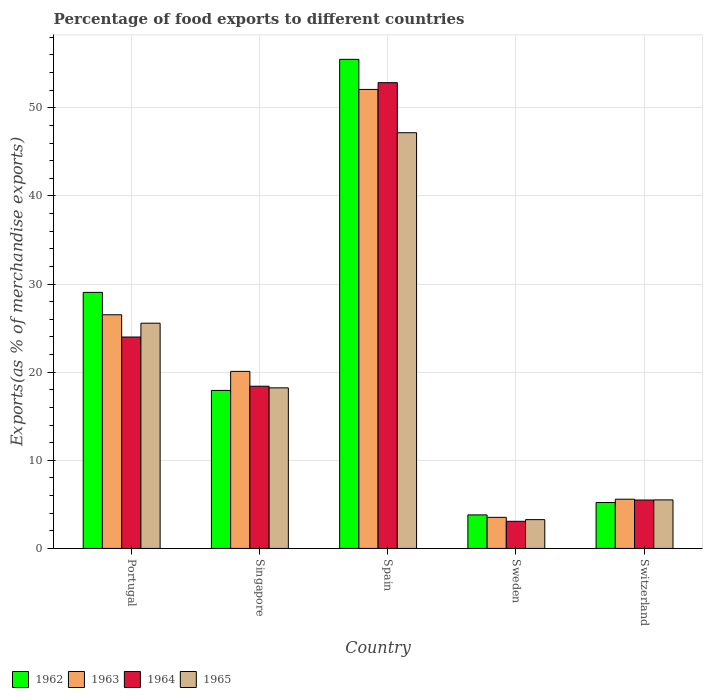How many different coloured bars are there?
Make the answer very short. 4. How many groups of bars are there?
Ensure brevity in your answer.  5. How many bars are there on the 4th tick from the left?
Ensure brevity in your answer.  4. What is the percentage of exports to different countries in 1964 in Switzerland?
Your answer should be very brief. 5.49. Across all countries, what is the maximum percentage of exports to different countries in 1962?
Offer a very short reply. 55.5. Across all countries, what is the minimum percentage of exports to different countries in 1963?
Make the answer very short. 3.53. In which country was the percentage of exports to different countries in 1963 minimum?
Keep it short and to the point. Sweden. What is the total percentage of exports to different countries in 1962 in the graph?
Your response must be concise. 111.5. What is the difference between the percentage of exports to different countries in 1965 in Portugal and that in Sweden?
Provide a short and direct response. 22.29. What is the difference between the percentage of exports to different countries in 1963 in Switzerland and the percentage of exports to different countries in 1962 in Spain?
Ensure brevity in your answer.  -49.92. What is the average percentage of exports to different countries in 1965 per country?
Make the answer very short. 19.95. What is the difference between the percentage of exports to different countries of/in 1962 and percentage of exports to different countries of/in 1963 in Singapore?
Provide a short and direct response. -2.16. What is the ratio of the percentage of exports to different countries in 1964 in Portugal to that in Sweden?
Give a very brief answer. 7.79. Is the percentage of exports to different countries in 1964 in Singapore less than that in Sweden?
Offer a terse response. No. Is the difference between the percentage of exports to different countries in 1962 in Spain and Switzerland greater than the difference between the percentage of exports to different countries in 1963 in Spain and Switzerland?
Your answer should be very brief. Yes. What is the difference between the highest and the second highest percentage of exports to different countries in 1964?
Your answer should be very brief. -34.45. What is the difference between the highest and the lowest percentage of exports to different countries in 1962?
Make the answer very short. 51.7. In how many countries, is the percentage of exports to different countries in 1965 greater than the average percentage of exports to different countries in 1965 taken over all countries?
Provide a succinct answer. 2. What does the 1st bar from the left in Singapore represents?
Offer a terse response. 1962. What does the 4th bar from the right in Singapore represents?
Give a very brief answer. 1962. How many bars are there?
Keep it short and to the point. 20. How many countries are there in the graph?
Give a very brief answer. 5. What is the difference between two consecutive major ticks on the Y-axis?
Keep it short and to the point. 10. Does the graph contain any zero values?
Keep it short and to the point. No. What is the title of the graph?
Offer a very short reply. Percentage of food exports to different countries. What is the label or title of the X-axis?
Provide a short and direct response. Country. What is the label or title of the Y-axis?
Ensure brevity in your answer.  Exports(as % of merchandise exports). What is the Exports(as % of merchandise exports) in 1962 in Portugal?
Keep it short and to the point. 29.05. What is the Exports(as % of merchandise exports) of 1963 in Portugal?
Keep it short and to the point. 26.51. What is the Exports(as % of merchandise exports) in 1964 in Portugal?
Your answer should be compact. 23.99. What is the Exports(as % of merchandise exports) of 1965 in Portugal?
Offer a very short reply. 25.56. What is the Exports(as % of merchandise exports) in 1962 in Singapore?
Offer a terse response. 17.93. What is the Exports(as % of merchandise exports) of 1963 in Singapore?
Keep it short and to the point. 20.09. What is the Exports(as % of merchandise exports) of 1964 in Singapore?
Ensure brevity in your answer.  18.41. What is the Exports(as % of merchandise exports) in 1965 in Singapore?
Offer a terse response. 18.22. What is the Exports(as % of merchandise exports) of 1962 in Spain?
Keep it short and to the point. 55.5. What is the Exports(as % of merchandise exports) of 1963 in Spain?
Offer a very short reply. 52.09. What is the Exports(as % of merchandise exports) in 1964 in Spain?
Offer a very short reply. 52.85. What is the Exports(as % of merchandise exports) in 1965 in Spain?
Ensure brevity in your answer.  47.17. What is the Exports(as % of merchandise exports) in 1962 in Sweden?
Your answer should be compact. 3.8. What is the Exports(as % of merchandise exports) in 1963 in Sweden?
Provide a succinct answer. 3.53. What is the Exports(as % of merchandise exports) in 1964 in Sweden?
Provide a succinct answer. 3.08. What is the Exports(as % of merchandise exports) in 1965 in Sweden?
Make the answer very short. 3.27. What is the Exports(as % of merchandise exports) in 1962 in Switzerland?
Your answer should be compact. 5.21. What is the Exports(as % of merchandise exports) in 1963 in Switzerland?
Ensure brevity in your answer.  5.59. What is the Exports(as % of merchandise exports) in 1964 in Switzerland?
Offer a terse response. 5.49. What is the Exports(as % of merchandise exports) in 1965 in Switzerland?
Keep it short and to the point. 5.51. Across all countries, what is the maximum Exports(as % of merchandise exports) in 1962?
Make the answer very short. 55.5. Across all countries, what is the maximum Exports(as % of merchandise exports) of 1963?
Give a very brief answer. 52.09. Across all countries, what is the maximum Exports(as % of merchandise exports) of 1964?
Offer a very short reply. 52.85. Across all countries, what is the maximum Exports(as % of merchandise exports) of 1965?
Provide a short and direct response. 47.17. Across all countries, what is the minimum Exports(as % of merchandise exports) of 1962?
Give a very brief answer. 3.8. Across all countries, what is the minimum Exports(as % of merchandise exports) of 1963?
Keep it short and to the point. 3.53. Across all countries, what is the minimum Exports(as % of merchandise exports) in 1964?
Give a very brief answer. 3.08. Across all countries, what is the minimum Exports(as % of merchandise exports) of 1965?
Offer a very short reply. 3.27. What is the total Exports(as % of merchandise exports) in 1962 in the graph?
Offer a terse response. 111.5. What is the total Exports(as % of merchandise exports) of 1963 in the graph?
Your answer should be very brief. 107.81. What is the total Exports(as % of merchandise exports) in 1964 in the graph?
Keep it short and to the point. 103.82. What is the total Exports(as % of merchandise exports) in 1965 in the graph?
Provide a short and direct response. 99.73. What is the difference between the Exports(as % of merchandise exports) in 1962 in Portugal and that in Singapore?
Your response must be concise. 11.12. What is the difference between the Exports(as % of merchandise exports) of 1963 in Portugal and that in Singapore?
Make the answer very short. 6.42. What is the difference between the Exports(as % of merchandise exports) of 1964 in Portugal and that in Singapore?
Provide a short and direct response. 5.58. What is the difference between the Exports(as % of merchandise exports) of 1965 in Portugal and that in Singapore?
Provide a short and direct response. 7.34. What is the difference between the Exports(as % of merchandise exports) of 1962 in Portugal and that in Spain?
Your answer should be very brief. -26.45. What is the difference between the Exports(as % of merchandise exports) in 1963 in Portugal and that in Spain?
Your response must be concise. -25.57. What is the difference between the Exports(as % of merchandise exports) in 1964 in Portugal and that in Spain?
Your answer should be compact. -28.86. What is the difference between the Exports(as % of merchandise exports) in 1965 in Portugal and that in Spain?
Keep it short and to the point. -21.61. What is the difference between the Exports(as % of merchandise exports) in 1962 in Portugal and that in Sweden?
Offer a very short reply. 25.25. What is the difference between the Exports(as % of merchandise exports) in 1963 in Portugal and that in Sweden?
Keep it short and to the point. 22.98. What is the difference between the Exports(as % of merchandise exports) of 1964 in Portugal and that in Sweden?
Your answer should be compact. 20.91. What is the difference between the Exports(as % of merchandise exports) of 1965 in Portugal and that in Sweden?
Your answer should be very brief. 22.29. What is the difference between the Exports(as % of merchandise exports) in 1962 in Portugal and that in Switzerland?
Your response must be concise. 23.85. What is the difference between the Exports(as % of merchandise exports) of 1963 in Portugal and that in Switzerland?
Provide a succinct answer. 20.93. What is the difference between the Exports(as % of merchandise exports) of 1964 in Portugal and that in Switzerland?
Provide a short and direct response. 18.5. What is the difference between the Exports(as % of merchandise exports) in 1965 in Portugal and that in Switzerland?
Your answer should be very brief. 20.05. What is the difference between the Exports(as % of merchandise exports) of 1962 in Singapore and that in Spain?
Offer a very short reply. -37.57. What is the difference between the Exports(as % of merchandise exports) in 1963 in Singapore and that in Spain?
Ensure brevity in your answer.  -31.99. What is the difference between the Exports(as % of merchandise exports) in 1964 in Singapore and that in Spain?
Offer a terse response. -34.45. What is the difference between the Exports(as % of merchandise exports) in 1965 in Singapore and that in Spain?
Provide a succinct answer. -28.95. What is the difference between the Exports(as % of merchandise exports) in 1962 in Singapore and that in Sweden?
Offer a very short reply. 14.13. What is the difference between the Exports(as % of merchandise exports) of 1963 in Singapore and that in Sweden?
Offer a very short reply. 16.56. What is the difference between the Exports(as % of merchandise exports) of 1964 in Singapore and that in Sweden?
Your answer should be compact. 15.33. What is the difference between the Exports(as % of merchandise exports) in 1965 in Singapore and that in Sweden?
Your response must be concise. 14.95. What is the difference between the Exports(as % of merchandise exports) in 1962 in Singapore and that in Switzerland?
Provide a short and direct response. 12.72. What is the difference between the Exports(as % of merchandise exports) in 1963 in Singapore and that in Switzerland?
Your answer should be compact. 14.51. What is the difference between the Exports(as % of merchandise exports) in 1964 in Singapore and that in Switzerland?
Ensure brevity in your answer.  12.91. What is the difference between the Exports(as % of merchandise exports) of 1965 in Singapore and that in Switzerland?
Your response must be concise. 12.71. What is the difference between the Exports(as % of merchandise exports) of 1962 in Spain and that in Sweden?
Ensure brevity in your answer.  51.7. What is the difference between the Exports(as % of merchandise exports) in 1963 in Spain and that in Sweden?
Make the answer very short. 48.56. What is the difference between the Exports(as % of merchandise exports) of 1964 in Spain and that in Sweden?
Keep it short and to the point. 49.77. What is the difference between the Exports(as % of merchandise exports) of 1965 in Spain and that in Sweden?
Provide a succinct answer. 43.9. What is the difference between the Exports(as % of merchandise exports) of 1962 in Spain and that in Switzerland?
Your answer should be compact. 50.29. What is the difference between the Exports(as % of merchandise exports) in 1963 in Spain and that in Switzerland?
Make the answer very short. 46.5. What is the difference between the Exports(as % of merchandise exports) in 1964 in Spain and that in Switzerland?
Your answer should be very brief. 47.36. What is the difference between the Exports(as % of merchandise exports) in 1965 in Spain and that in Switzerland?
Keep it short and to the point. 41.67. What is the difference between the Exports(as % of merchandise exports) in 1962 in Sweden and that in Switzerland?
Your answer should be very brief. -1.4. What is the difference between the Exports(as % of merchandise exports) of 1963 in Sweden and that in Switzerland?
Provide a short and direct response. -2.06. What is the difference between the Exports(as % of merchandise exports) of 1964 in Sweden and that in Switzerland?
Your response must be concise. -2.41. What is the difference between the Exports(as % of merchandise exports) in 1965 in Sweden and that in Switzerland?
Provide a short and direct response. -2.24. What is the difference between the Exports(as % of merchandise exports) in 1962 in Portugal and the Exports(as % of merchandise exports) in 1963 in Singapore?
Your answer should be compact. 8.96. What is the difference between the Exports(as % of merchandise exports) in 1962 in Portugal and the Exports(as % of merchandise exports) in 1964 in Singapore?
Offer a terse response. 10.65. What is the difference between the Exports(as % of merchandise exports) of 1962 in Portugal and the Exports(as % of merchandise exports) of 1965 in Singapore?
Your answer should be very brief. 10.83. What is the difference between the Exports(as % of merchandise exports) in 1963 in Portugal and the Exports(as % of merchandise exports) in 1964 in Singapore?
Provide a short and direct response. 8.11. What is the difference between the Exports(as % of merchandise exports) of 1963 in Portugal and the Exports(as % of merchandise exports) of 1965 in Singapore?
Give a very brief answer. 8.29. What is the difference between the Exports(as % of merchandise exports) of 1964 in Portugal and the Exports(as % of merchandise exports) of 1965 in Singapore?
Your answer should be compact. 5.77. What is the difference between the Exports(as % of merchandise exports) in 1962 in Portugal and the Exports(as % of merchandise exports) in 1963 in Spain?
Your answer should be compact. -23.03. What is the difference between the Exports(as % of merchandise exports) of 1962 in Portugal and the Exports(as % of merchandise exports) of 1964 in Spain?
Make the answer very short. -23.8. What is the difference between the Exports(as % of merchandise exports) of 1962 in Portugal and the Exports(as % of merchandise exports) of 1965 in Spain?
Provide a succinct answer. -18.12. What is the difference between the Exports(as % of merchandise exports) in 1963 in Portugal and the Exports(as % of merchandise exports) in 1964 in Spain?
Your answer should be compact. -26.34. What is the difference between the Exports(as % of merchandise exports) in 1963 in Portugal and the Exports(as % of merchandise exports) in 1965 in Spain?
Your response must be concise. -20.66. What is the difference between the Exports(as % of merchandise exports) of 1964 in Portugal and the Exports(as % of merchandise exports) of 1965 in Spain?
Your answer should be compact. -23.18. What is the difference between the Exports(as % of merchandise exports) of 1962 in Portugal and the Exports(as % of merchandise exports) of 1963 in Sweden?
Ensure brevity in your answer.  25.53. What is the difference between the Exports(as % of merchandise exports) of 1962 in Portugal and the Exports(as % of merchandise exports) of 1964 in Sweden?
Provide a succinct answer. 25.98. What is the difference between the Exports(as % of merchandise exports) of 1962 in Portugal and the Exports(as % of merchandise exports) of 1965 in Sweden?
Provide a succinct answer. 25.79. What is the difference between the Exports(as % of merchandise exports) in 1963 in Portugal and the Exports(as % of merchandise exports) in 1964 in Sweden?
Your response must be concise. 23.44. What is the difference between the Exports(as % of merchandise exports) of 1963 in Portugal and the Exports(as % of merchandise exports) of 1965 in Sweden?
Make the answer very short. 23.25. What is the difference between the Exports(as % of merchandise exports) in 1964 in Portugal and the Exports(as % of merchandise exports) in 1965 in Sweden?
Your answer should be compact. 20.72. What is the difference between the Exports(as % of merchandise exports) of 1962 in Portugal and the Exports(as % of merchandise exports) of 1963 in Switzerland?
Provide a short and direct response. 23.47. What is the difference between the Exports(as % of merchandise exports) of 1962 in Portugal and the Exports(as % of merchandise exports) of 1964 in Switzerland?
Offer a terse response. 23.56. What is the difference between the Exports(as % of merchandise exports) in 1962 in Portugal and the Exports(as % of merchandise exports) in 1965 in Switzerland?
Make the answer very short. 23.55. What is the difference between the Exports(as % of merchandise exports) in 1963 in Portugal and the Exports(as % of merchandise exports) in 1964 in Switzerland?
Your answer should be very brief. 21.02. What is the difference between the Exports(as % of merchandise exports) in 1963 in Portugal and the Exports(as % of merchandise exports) in 1965 in Switzerland?
Your answer should be compact. 21.01. What is the difference between the Exports(as % of merchandise exports) in 1964 in Portugal and the Exports(as % of merchandise exports) in 1965 in Switzerland?
Offer a very short reply. 18.48. What is the difference between the Exports(as % of merchandise exports) of 1962 in Singapore and the Exports(as % of merchandise exports) of 1963 in Spain?
Ensure brevity in your answer.  -34.16. What is the difference between the Exports(as % of merchandise exports) in 1962 in Singapore and the Exports(as % of merchandise exports) in 1964 in Spain?
Provide a succinct answer. -34.92. What is the difference between the Exports(as % of merchandise exports) in 1962 in Singapore and the Exports(as % of merchandise exports) in 1965 in Spain?
Make the answer very short. -29.24. What is the difference between the Exports(as % of merchandise exports) of 1963 in Singapore and the Exports(as % of merchandise exports) of 1964 in Spain?
Provide a succinct answer. -32.76. What is the difference between the Exports(as % of merchandise exports) in 1963 in Singapore and the Exports(as % of merchandise exports) in 1965 in Spain?
Ensure brevity in your answer.  -27.08. What is the difference between the Exports(as % of merchandise exports) in 1964 in Singapore and the Exports(as % of merchandise exports) in 1965 in Spain?
Ensure brevity in your answer.  -28.77. What is the difference between the Exports(as % of merchandise exports) in 1962 in Singapore and the Exports(as % of merchandise exports) in 1963 in Sweden?
Give a very brief answer. 14.4. What is the difference between the Exports(as % of merchandise exports) in 1962 in Singapore and the Exports(as % of merchandise exports) in 1964 in Sweden?
Offer a very short reply. 14.85. What is the difference between the Exports(as % of merchandise exports) of 1962 in Singapore and the Exports(as % of merchandise exports) of 1965 in Sweden?
Keep it short and to the point. 14.66. What is the difference between the Exports(as % of merchandise exports) of 1963 in Singapore and the Exports(as % of merchandise exports) of 1964 in Sweden?
Offer a terse response. 17.01. What is the difference between the Exports(as % of merchandise exports) in 1963 in Singapore and the Exports(as % of merchandise exports) in 1965 in Sweden?
Offer a terse response. 16.83. What is the difference between the Exports(as % of merchandise exports) in 1964 in Singapore and the Exports(as % of merchandise exports) in 1965 in Sweden?
Provide a succinct answer. 15.14. What is the difference between the Exports(as % of merchandise exports) in 1962 in Singapore and the Exports(as % of merchandise exports) in 1963 in Switzerland?
Offer a terse response. 12.34. What is the difference between the Exports(as % of merchandise exports) of 1962 in Singapore and the Exports(as % of merchandise exports) of 1964 in Switzerland?
Keep it short and to the point. 12.44. What is the difference between the Exports(as % of merchandise exports) in 1962 in Singapore and the Exports(as % of merchandise exports) in 1965 in Switzerland?
Your answer should be very brief. 12.42. What is the difference between the Exports(as % of merchandise exports) in 1963 in Singapore and the Exports(as % of merchandise exports) in 1964 in Switzerland?
Provide a succinct answer. 14.6. What is the difference between the Exports(as % of merchandise exports) in 1963 in Singapore and the Exports(as % of merchandise exports) in 1965 in Switzerland?
Offer a very short reply. 14.59. What is the difference between the Exports(as % of merchandise exports) in 1964 in Singapore and the Exports(as % of merchandise exports) in 1965 in Switzerland?
Make the answer very short. 12.9. What is the difference between the Exports(as % of merchandise exports) of 1962 in Spain and the Exports(as % of merchandise exports) of 1963 in Sweden?
Your answer should be compact. 51.97. What is the difference between the Exports(as % of merchandise exports) of 1962 in Spain and the Exports(as % of merchandise exports) of 1964 in Sweden?
Provide a short and direct response. 52.42. What is the difference between the Exports(as % of merchandise exports) in 1962 in Spain and the Exports(as % of merchandise exports) in 1965 in Sweden?
Offer a terse response. 52.23. What is the difference between the Exports(as % of merchandise exports) in 1963 in Spain and the Exports(as % of merchandise exports) in 1964 in Sweden?
Make the answer very short. 49.01. What is the difference between the Exports(as % of merchandise exports) of 1963 in Spain and the Exports(as % of merchandise exports) of 1965 in Sweden?
Offer a terse response. 48.82. What is the difference between the Exports(as % of merchandise exports) in 1964 in Spain and the Exports(as % of merchandise exports) in 1965 in Sweden?
Provide a succinct answer. 49.58. What is the difference between the Exports(as % of merchandise exports) of 1962 in Spain and the Exports(as % of merchandise exports) of 1963 in Switzerland?
Offer a very short reply. 49.92. What is the difference between the Exports(as % of merchandise exports) in 1962 in Spain and the Exports(as % of merchandise exports) in 1964 in Switzerland?
Offer a terse response. 50.01. What is the difference between the Exports(as % of merchandise exports) in 1962 in Spain and the Exports(as % of merchandise exports) in 1965 in Switzerland?
Make the answer very short. 49.99. What is the difference between the Exports(as % of merchandise exports) in 1963 in Spain and the Exports(as % of merchandise exports) in 1964 in Switzerland?
Make the answer very short. 46.59. What is the difference between the Exports(as % of merchandise exports) in 1963 in Spain and the Exports(as % of merchandise exports) in 1965 in Switzerland?
Offer a very short reply. 46.58. What is the difference between the Exports(as % of merchandise exports) of 1964 in Spain and the Exports(as % of merchandise exports) of 1965 in Switzerland?
Your response must be concise. 47.35. What is the difference between the Exports(as % of merchandise exports) in 1962 in Sweden and the Exports(as % of merchandise exports) in 1963 in Switzerland?
Give a very brief answer. -1.78. What is the difference between the Exports(as % of merchandise exports) in 1962 in Sweden and the Exports(as % of merchandise exports) in 1964 in Switzerland?
Provide a succinct answer. -1.69. What is the difference between the Exports(as % of merchandise exports) in 1962 in Sweden and the Exports(as % of merchandise exports) in 1965 in Switzerland?
Keep it short and to the point. -1.7. What is the difference between the Exports(as % of merchandise exports) of 1963 in Sweden and the Exports(as % of merchandise exports) of 1964 in Switzerland?
Make the answer very short. -1.96. What is the difference between the Exports(as % of merchandise exports) in 1963 in Sweden and the Exports(as % of merchandise exports) in 1965 in Switzerland?
Keep it short and to the point. -1.98. What is the difference between the Exports(as % of merchandise exports) in 1964 in Sweden and the Exports(as % of merchandise exports) in 1965 in Switzerland?
Keep it short and to the point. -2.43. What is the average Exports(as % of merchandise exports) of 1962 per country?
Make the answer very short. 22.3. What is the average Exports(as % of merchandise exports) in 1963 per country?
Your answer should be very brief. 21.56. What is the average Exports(as % of merchandise exports) of 1964 per country?
Your answer should be very brief. 20.76. What is the average Exports(as % of merchandise exports) of 1965 per country?
Keep it short and to the point. 19.95. What is the difference between the Exports(as % of merchandise exports) of 1962 and Exports(as % of merchandise exports) of 1963 in Portugal?
Provide a succinct answer. 2.54. What is the difference between the Exports(as % of merchandise exports) of 1962 and Exports(as % of merchandise exports) of 1964 in Portugal?
Provide a succinct answer. 5.06. What is the difference between the Exports(as % of merchandise exports) of 1962 and Exports(as % of merchandise exports) of 1965 in Portugal?
Provide a succinct answer. 3.49. What is the difference between the Exports(as % of merchandise exports) of 1963 and Exports(as % of merchandise exports) of 1964 in Portugal?
Your answer should be very brief. 2.52. What is the difference between the Exports(as % of merchandise exports) of 1963 and Exports(as % of merchandise exports) of 1965 in Portugal?
Offer a very short reply. 0.95. What is the difference between the Exports(as % of merchandise exports) in 1964 and Exports(as % of merchandise exports) in 1965 in Portugal?
Offer a terse response. -1.57. What is the difference between the Exports(as % of merchandise exports) of 1962 and Exports(as % of merchandise exports) of 1963 in Singapore?
Offer a very short reply. -2.16. What is the difference between the Exports(as % of merchandise exports) in 1962 and Exports(as % of merchandise exports) in 1964 in Singapore?
Offer a very short reply. -0.48. What is the difference between the Exports(as % of merchandise exports) of 1962 and Exports(as % of merchandise exports) of 1965 in Singapore?
Make the answer very short. -0.29. What is the difference between the Exports(as % of merchandise exports) of 1963 and Exports(as % of merchandise exports) of 1964 in Singapore?
Ensure brevity in your answer.  1.69. What is the difference between the Exports(as % of merchandise exports) of 1963 and Exports(as % of merchandise exports) of 1965 in Singapore?
Your answer should be very brief. 1.87. What is the difference between the Exports(as % of merchandise exports) of 1964 and Exports(as % of merchandise exports) of 1965 in Singapore?
Keep it short and to the point. 0.18. What is the difference between the Exports(as % of merchandise exports) in 1962 and Exports(as % of merchandise exports) in 1963 in Spain?
Provide a succinct answer. 3.42. What is the difference between the Exports(as % of merchandise exports) in 1962 and Exports(as % of merchandise exports) in 1964 in Spain?
Offer a terse response. 2.65. What is the difference between the Exports(as % of merchandise exports) of 1962 and Exports(as % of merchandise exports) of 1965 in Spain?
Offer a terse response. 8.33. What is the difference between the Exports(as % of merchandise exports) in 1963 and Exports(as % of merchandise exports) in 1964 in Spain?
Offer a very short reply. -0.77. What is the difference between the Exports(as % of merchandise exports) of 1963 and Exports(as % of merchandise exports) of 1965 in Spain?
Ensure brevity in your answer.  4.91. What is the difference between the Exports(as % of merchandise exports) in 1964 and Exports(as % of merchandise exports) in 1965 in Spain?
Your answer should be compact. 5.68. What is the difference between the Exports(as % of merchandise exports) of 1962 and Exports(as % of merchandise exports) of 1963 in Sweden?
Provide a succinct answer. 0.28. What is the difference between the Exports(as % of merchandise exports) in 1962 and Exports(as % of merchandise exports) in 1964 in Sweden?
Provide a short and direct response. 0.73. What is the difference between the Exports(as % of merchandise exports) in 1962 and Exports(as % of merchandise exports) in 1965 in Sweden?
Ensure brevity in your answer.  0.54. What is the difference between the Exports(as % of merchandise exports) of 1963 and Exports(as % of merchandise exports) of 1964 in Sweden?
Your answer should be very brief. 0.45. What is the difference between the Exports(as % of merchandise exports) of 1963 and Exports(as % of merchandise exports) of 1965 in Sweden?
Your answer should be compact. 0.26. What is the difference between the Exports(as % of merchandise exports) in 1964 and Exports(as % of merchandise exports) in 1965 in Sweden?
Offer a very short reply. -0.19. What is the difference between the Exports(as % of merchandise exports) in 1962 and Exports(as % of merchandise exports) in 1963 in Switzerland?
Give a very brief answer. -0.38. What is the difference between the Exports(as % of merchandise exports) in 1962 and Exports(as % of merchandise exports) in 1964 in Switzerland?
Keep it short and to the point. -0.28. What is the difference between the Exports(as % of merchandise exports) of 1962 and Exports(as % of merchandise exports) of 1965 in Switzerland?
Provide a short and direct response. -0.3. What is the difference between the Exports(as % of merchandise exports) in 1963 and Exports(as % of merchandise exports) in 1964 in Switzerland?
Make the answer very short. 0.09. What is the difference between the Exports(as % of merchandise exports) in 1963 and Exports(as % of merchandise exports) in 1965 in Switzerland?
Give a very brief answer. 0.08. What is the difference between the Exports(as % of merchandise exports) of 1964 and Exports(as % of merchandise exports) of 1965 in Switzerland?
Offer a very short reply. -0.01. What is the ratio of the Exports(as % of merchandise exports) in 1962 in Portugal to that in Singapore?
Keep it short and to the point. 1.62. What is the ratio of the Exports(as % of merchandise exports) in 1963 in Portugal to that in Singapore?
Your response must be concise. 1.32. What is the ratio of the Exports(as % of merchandise exports) of 1964 in Portugal to that in Singapore?
Offer a very short reply. 1.3. What is the ratio of the Exports(as % of merchandise exports) in 1965 in Portugal to that in Singapore?
Provide a short and direct response. 1.4. What is the ratio of the Exports(as % of merchandise exports) in 1962 in Portugal to that in Spain?
Your answer should be very brief. 0.52. What is the ratio of the Exports(as % of merchandise exports) in 1963 in Portugal to that in Spain?
Offer a terse response. 0.51. What is the ratio of the Exports(as % of merchandise exports) of 1964 in Portugal to that in Spain?
Offer a very short reply. 0.45. What is the ratio of the Exports(as % of merchandise exports) of 1965 in Portugal to that in Spain?
Provide a short and direct response. 0.54. What is the ratio of the Exports(as % of merchandise exports) in 1962 in Portugal to that in Sweden?
Your answer should be compact. 7.64. What is the ratio of the Exports(as % of merchandise exports) in 1963 in Portugal to that in Sweden?
Ensure brevity in your answer.  7.51. What is the ratio of the Exports(as % of merchandise exports) in 1964 in Portugal to that in Sweden?
Offer a terse response. 7.79. What is the ratio of the Exports(as % of merchandise exports) in 1965 in Portugal to that in Sweden?
Provide a succinct answer. 7.82. What is the ratio of the Exports(as % of merchandise exports) in 1962 in Portugal to that in Switzerland?
Ensure brevity in your answer.  5.58. What is the ratio of the Exports(as % of merchandise exports) of 1963 in Portugal to that in Switzerland?
Your answer should be very brief. 4.75. What is the ratio of the Exports(as % of merchandise exports) in 1964 in Portugal to that in Switzerland?
Make the answer very short. 4.37. What is the ratio of the Exports(as % of merchandise exports) of 1965 in Portugal to that in Switzerland?
Offer a very short reply. 4.64. What is the ratio of the Exports(as % of merchandise exports) in 1962 in Singapore to that in Spain?
Provide a succinct answer. 0.32. What is the ratio of the Exports(as % of merchandise exports) of 1963 in Singapore to that in Spain?
Offer a very short reply. 0.39. What is the ratio of the Exports(as % of merchandise exports) of 1964 in Singapore to that in Spain?
Offer a very short reply. 0.35. What is the ratio of the Exports(as % of merchandise exports) of 1965 in Singapore to that in Spain?
Provide a succinct answer. 0.39. What is the ratio of the Exports(as % of merchandise exports) of 1962 in Singapore to that in Sweden?
Offer a very short reply. 4.71. What is the ratio of the Exports(as % of merchandise exports) of 1963 in Singapore to that in Sweden?
Offer a very short reply. 5.69. What is the ratio of the Exports(as % of merchandise exports) of 1964 in Singapore to that in Sweden?
Your answer should be compact. 5.98. What is the ratio of the Exports(as % of merchandise exports) of 1965 in Singapore to that in Sweden?
Keep it short and to the point. 5.58. What is the ratio of the Exports(as % of merchandise exports) in 1962 in Singapore to that in Switzerland?
Your answer should be very brief. 3.44. What is the ratio of the Exports(as % of merchandise exports) of 1963 in Singapore to that in Switzerland?
Your answer should be very brief. 3.6. What is the ratio of the Exports(as % of merchandise exports) of 1964 in Singapore to that in Switzerland?
Offer a terse response. 3.35. What is the ratio of the Exports(as % of merchandise exports) of 1965 in Singapore to that in Switzerland?
Keep it short and to the point. 3.31. What is the ratio of the Exports(as % of merchandise exports) of 1962 in Spain to that in Sweden?
Your answer should be very brief. 14.59. What is the ratio of the Exports(as % of merchandise exports) in 1963 in Spain to that in Sweden?
Give a very brief answer. 14.76. What is the ratio of the Exports(as % of merchandise exports) in 1964 in Spain to that in Sweden?
Provide a short and direct response. 17.17. What is the ratio of the Exports(as % of merchandise exports) in 1965 in Spain to that in Sweden?
Your response must be concise. 14.44. What is the ratio of the Exports(as % of merchandise exports) in 1962 in Spain to that in Switzerland?
Your response must be concise. 10.65. What is the ratio of the Exports(as % of merchandise exports) of 1963 in Spain to that in Switzerland?
Offer a very short reply. 9.33. What is the ratio of the Exports(as % of merchandise exports) of 1964 in Spain to that in Switzerland?
Offer a terse response. 9.62. What is the ratio of the Exports(as % of merchandise exports) in 1965 in Spain to that in Switzerland?
Give a very brief answer. 8.57. What is the ratio of the Exports(as % of merchandise exports) of 1962 in Sweden to that in Switzerland?
Provide a short and direct response. 0.73. What is the ratio of the Exports(as % of merchandise exports) of 1963 in Sweden to that in Switzerland?
Your response must be concise. 0.63. What is the ratio of the Exports(as % of merchandise exports) in 1964 in Sweden to that in Switzerland?
Keep it short and to the point. 0.56. What is the ratio of the Exports(as % of merchandise exports) of 1965 in Sweden to that in Switzerland?
Provide a succinct answer. 0.59. What is the difference between the highest and the second highest Exports(as % of merchandise exports) in 1962?
Keep it short and to the point. 26.45. What is the difference between the highest and the second highest Exports(as % of merchandise exports) of 1963?
Provide a succinct answer. 25.57. What is the difference between the highest and the second highest Exports(as % of merchandise exports) in 1964?
Your response must be concise. 28.86. What is the difference between the highest and the second highest Exports(as % of merchandise exports) of 1965?
Provide a succinct answer. 21.61. What is the difference between the highest and the lowest Exports(as % of merchandise exports) of 1962?
Ensure brevity in your answer.  51.7. What is the difference between the highest and the lowest Exports(as % of merchandise exports) of 1963?
Provide a succinct answer. 48.56. What is the difference between the highest and the lowest Exports(as % of merchandise exports) in 1964?
Give a very brief answer. 49.77. What is the difference between the highest and the lowest Exports(as % of merchandise exports) in 1965?
Provide a short and direct response. 43.9. 